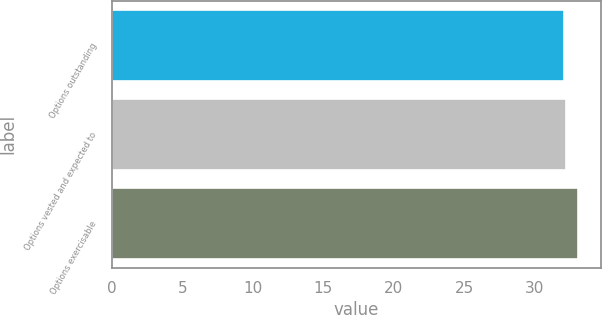Convert chart. <chart><loc_0><loc_0><loc_500><loc_500><bar_chart><fcel>Options outstanding<fcel>Options vested and expected to<fcel>Options exercisable<nl><fcel>32.09<fcel>32.19<fcel>33.06<nl></chart> 